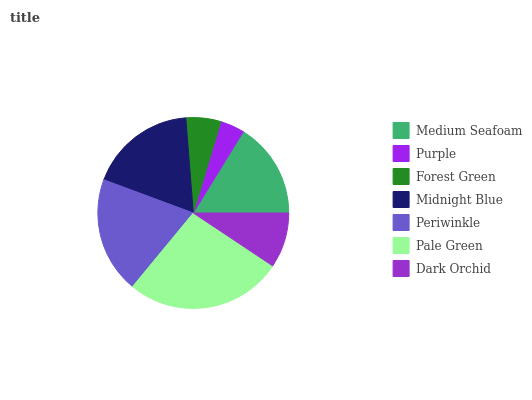Is Purple the minimum?
Answer yes or no. Yes. Is Pale Green the maximum?
Answer yes or no. Yes. Is Forest Green the minimum?
Answer yes or no. No. Is Forest Green the maximum?
Answer yes or no. No. Is Forest Green greater than Purple?
Answer yes or no. Yes. Is Purple less than Forest Green?
Answer yes or no. Yes. Is Purple greater than Forest Green?
Answer yes or no. No. Is Forest Green less than Purple?
Answer yes or no. No. Is Medium Seafoam the high median?
Answer yes or no. Yes. Is Medium Seafoam the low median?
Answer yes or no. Yes. Is Purple the high median?
Answer yes or no. No. Is Midnight Blue the low median?
Answer yes or no. No. 